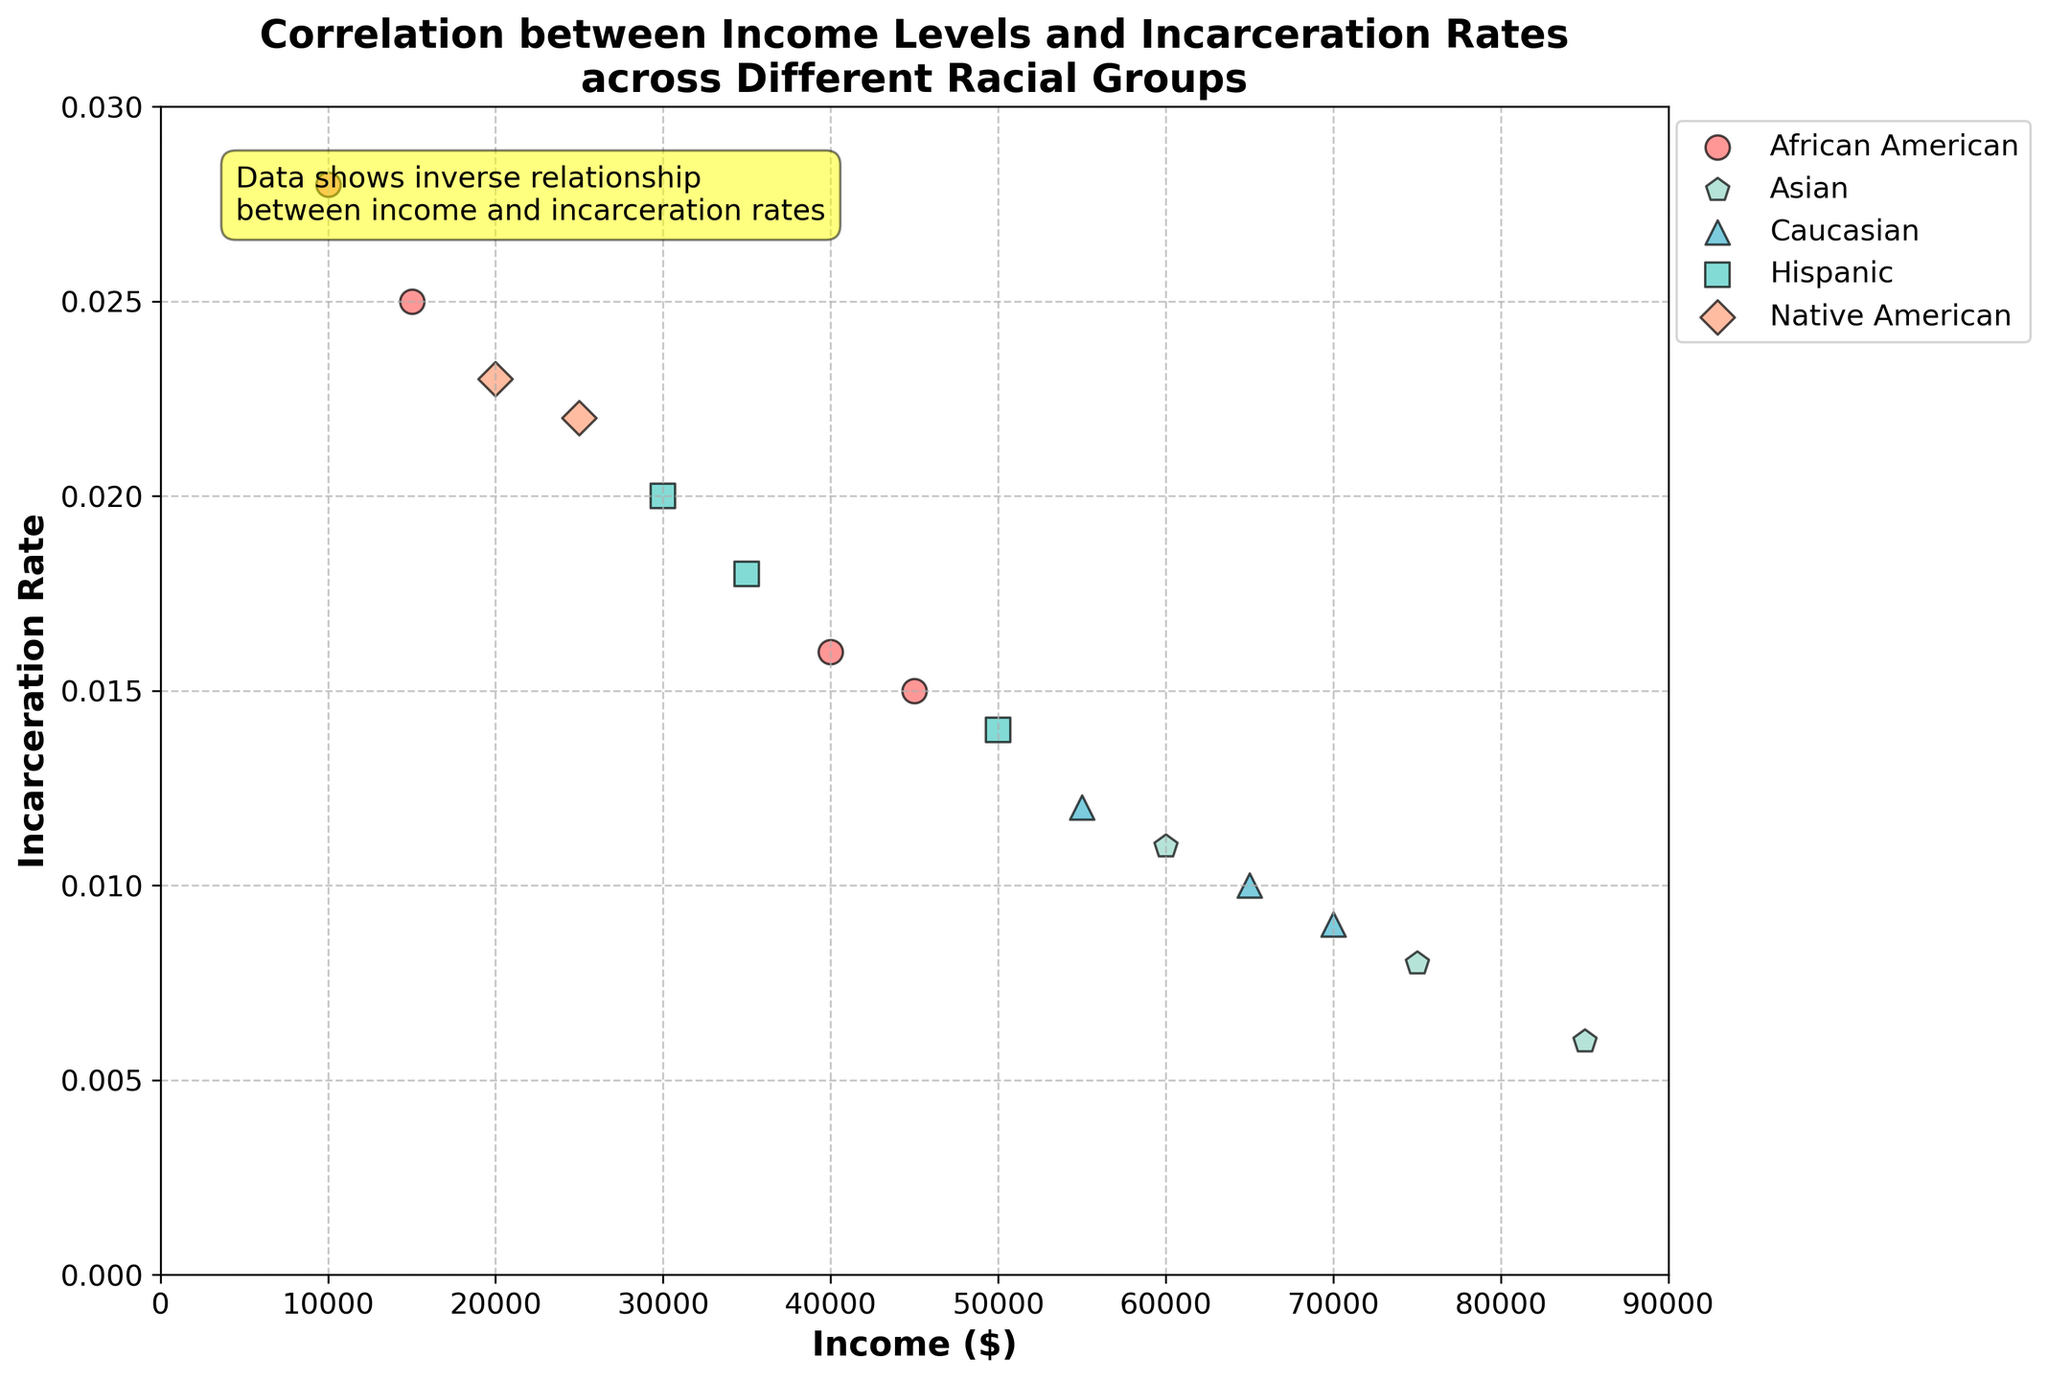What is the title of the figure? The title is written at the top of the figure and provides a description of what the plot is about, usually giving context to the data being visualized.
Answer: Correlation between Income Levels and Incarceration Rates across Different Racial Groups What are the labels for the x-axis and y-axis? The labels are displayed along the axes of the chart, with the x-axis usually at the bottom and the y-axis on the left side of the plot.
Answer: Income ($) and Incarceration Rate Which racial group has the lowest incarceration rate at the highest income level? By observing the plotted data points and the corresponding legend, we can identify the racial group represented by the marker placed highest up along the income axis with the lowest y-value (incarceration rate).
Answer: Asian How many African American data points are shown in the plot? By looking at the legend, identify the color and marker type for African Americans, then count those data points on the plot.
Answer: 4 How does the relationship between income and incarceration rate appear visually? One can describe the observed trend between the two variables: whether it looks like a positive, negative, or no correlation by observing the scatter pattern of the data points across the plot.
Answer: Inverse relationship Compare the incarceration rate between African American and Caucasian groups at approximately $55,000 income level. Locate the data points for both racial groups close to the $55,000 income mark and compare their y-values (incarceration rates). The point for African American is marked differently than Caucasian, facilitating comparison.
Answer: African Americans have a higher incarceration rate than Caucasians at $55,000 Which racial group shows the highest variability in incarceration rates across different income levels? Assess the spread of incarceration rates (y-values) within each racial group by looking at how dispersed their data points are vertically across different income levels on the plot.
Answer: African American What general observation can be made about the correlation between education level and employment status with respect to income and incarceration rate? Although the primary axes are income and incarceration rate, by observing the markers and colors, one can note trends like higher education levels correlating with lower incarceration rates and higher incomes, which can be inferred from the data points’ positions and associated legends.
Answer: Higher education and full-time employment tend to correlate with higher income and lower incarceration rate 